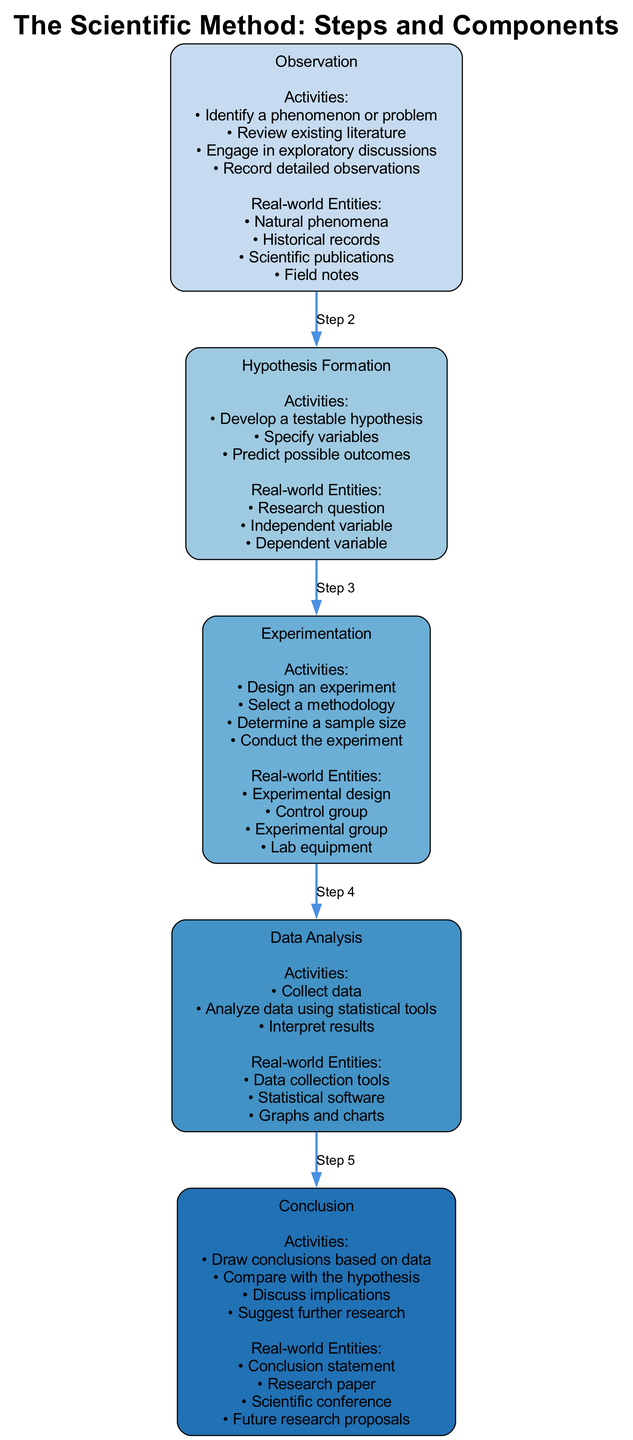What is the first step in the scientific method? The diagram clearly labels the first step as "Observation". This is determined from the order of the steps shown in the block diagram, where "Observation" is positioned at the top.
Answer: Observation How many activities are listed under the "Hypothesis Formation" step? Under the "Hypothesis Formation" block, there are three activities listed: "Develop a testable hypothesis", "Specify variables", and "Predict possible outcomes". This count can be directly observed within that block.
Answer: 3 Which step follows "Experimentation"? Based on the flow of the diagram, "Data Analysis" is the step that comes directly after "Experimentation", as each step connects sequentially in the block diagram.
Answer: Data Analysis What is a key activity in the "Data Analysis" step? The activities listed under "Data Analysis" include "Collect data", "Analyze data using statistical tools", and "Interpret results". Any of these could be considered a key activity, but one specifically is "Collect data", as it is foundational for the subsequent analysis.
Answer: Collect data What connects "Hypothesis Formation" to "Experimentation"? There is a directed edge labeled "Step 3" that clearly connects "Hypothesis Formation" to "Experimentation". This edge signifies the progression from one step to the next according to the methodology.
Answer: Step 3 In the "Observation" step, how many real-world entities are mentioned? The block for "Observation" contains four real-world entities: "Natural phenomena", "Historical records", "Scientific publications", and "Field notes". These entities are enumerated directly in the diagram under that section.
Answer: 4 What type of research outputs are suggested in the "Conclusion" step? The "Conclusion" block mentions several research outputs including "Conclusion statement", "Research paper", "Scientific conference", and "Future research proposals". These outputs are key outcomes from the conclusion of a scientific investigation.
Answer: Future research proposals What is a predictive element of the "Hypothesis Formation" step? "Predict possible outcomes" is clearly listed as an activity under "Hypothesis Formation". It represents the reasoning aspect where hypotheses are linked to expected results.
Answer: Predict possible outcomes Which block contains the activity "Conduct the experiment"? The activity "Conduct the experiment" is found within the "Experimentation" block. This can be established by checking the specifics laid out under each step in the diagram.
Answer: Experimentation 